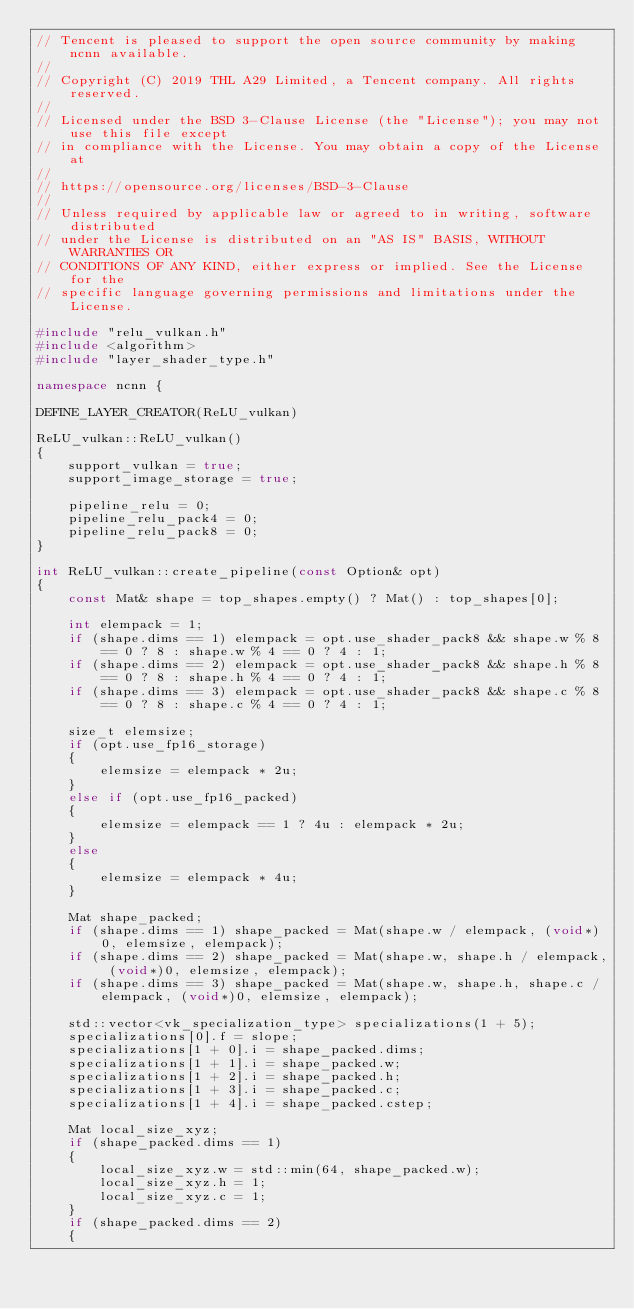Convert code to text. <code><loc_0><loc_0><loc_500><loc_500><_C++_>// Tencent is pleased to support the open source community by making ncnn available.
//
// Copyright (C) 2019 THL A29 Limited, a Tencent company. All rights reserved.
//
// Licensed under the BSD 3-Clause License (the "License"); you may not use this file except
// in compliance with the License. You may obtain a copy of the License at
//
// https://opensource.org/licenses/BSD-3-Clause
//
// Unless required by applicable law or agreed to in writing, software distributed
// under the License is distributed on an "AS IS" BASIS, WITHOUT WARRANTIES OR
// CONDITIONS OF ANY KIND, either express or implied. See the License for the
// specific language governing permissions and limitations under the License.

#include "relu_vulkan.h"
#include <algorithm>
#include "layer_shader_type.h"

namespace ncnn {

DEFINE_LAYER_CREATOR(ReLU_vulkan)

ReLU_vulkan::ReLU_vulkan()
{
    support_vulkan = true;
    support_image_storage = true;

    pipeline_relu = 0;
    pipeline_relu_pack4 = 0;
    pipeline_relu_pack8 = 0;
}

int ReLU_vulkan::create_pipeline(const Option& opt)
{
    const Mat& shape = top_shapes.empty() ? Mat() : top_shapes[0];

    int elempack = 1;
    if (shape.dims == 1) elempack = opt.use_shader_pack8 && shape.w % 8 == 0 ? 8 : shape.w % 4 == 0 ? 4 : 1;
    if (shape.dims == 2) elempack = opt.use_shader_pack8 && shape.h % 8 == 0 ? 8 : shape.h % 4 == 0 ? 4 : 1;
    if (shape.dims == 3) elempack = opt.use_shader_pack8 && shape.c % 8 == 0 ? 8 : shape.c % 4 == 0 ? 4 : 1;

    size_t elemsize;
    if (opt.use_fp16_storage)
    {
        elemsize = elempack * 2u;
    }
    else if (opt.use_fp16_packed)
    {
        elemsize = elempack == 1 ? 4u : elempack * 2u;
    }
    else
    {
        elemsize = elempack * 4u;
    }

    Mat shape_packed;
    if (shape.dims == 1) shape_packed = Mat(shape.w / elempack, (void*)0, elemsize, elempack);
    if (shape.dims == 2) shape_packed = Mat(shape.w, shape.h / elempack, (void*)0, elemsize, elempack);
    if (shape.dims == 3) shape_packed = Mat(shape.w, shape.h, shape.c / elempack, (void*)0, elemsize, elempack);

    std::vector<vk_specialization_type> specializations(1 + 5);
    specializations[0].f = slope;
    specializations[1 + 0].i = shape_packed.dims;
    specializations[1 + 1].i = shape_packed.w;
    specializations[1 + 2].i = shape_packed.h;
    specializations[1 + 3].i = shape_packed.c;
    specializations[1 + 4].i = shape_packed.cstep;

    Mat local_size_xyz;
    if (shape_packed.dims == 1)
    {
        local_size_xyz.w = std::min(64, shape_packed.w);
        local_size_xyz.h = 1;
        local_size_xyz.c = 1;
    }
    if (shape_packed.dims == 2)
    {</code> 